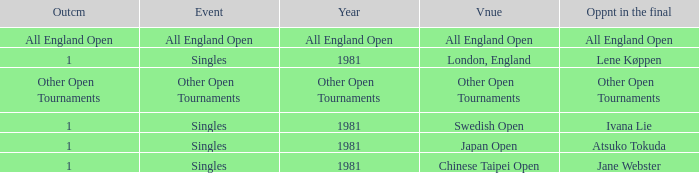What Event has an Outcome of other open tournaments? Other Open Tournaments. 